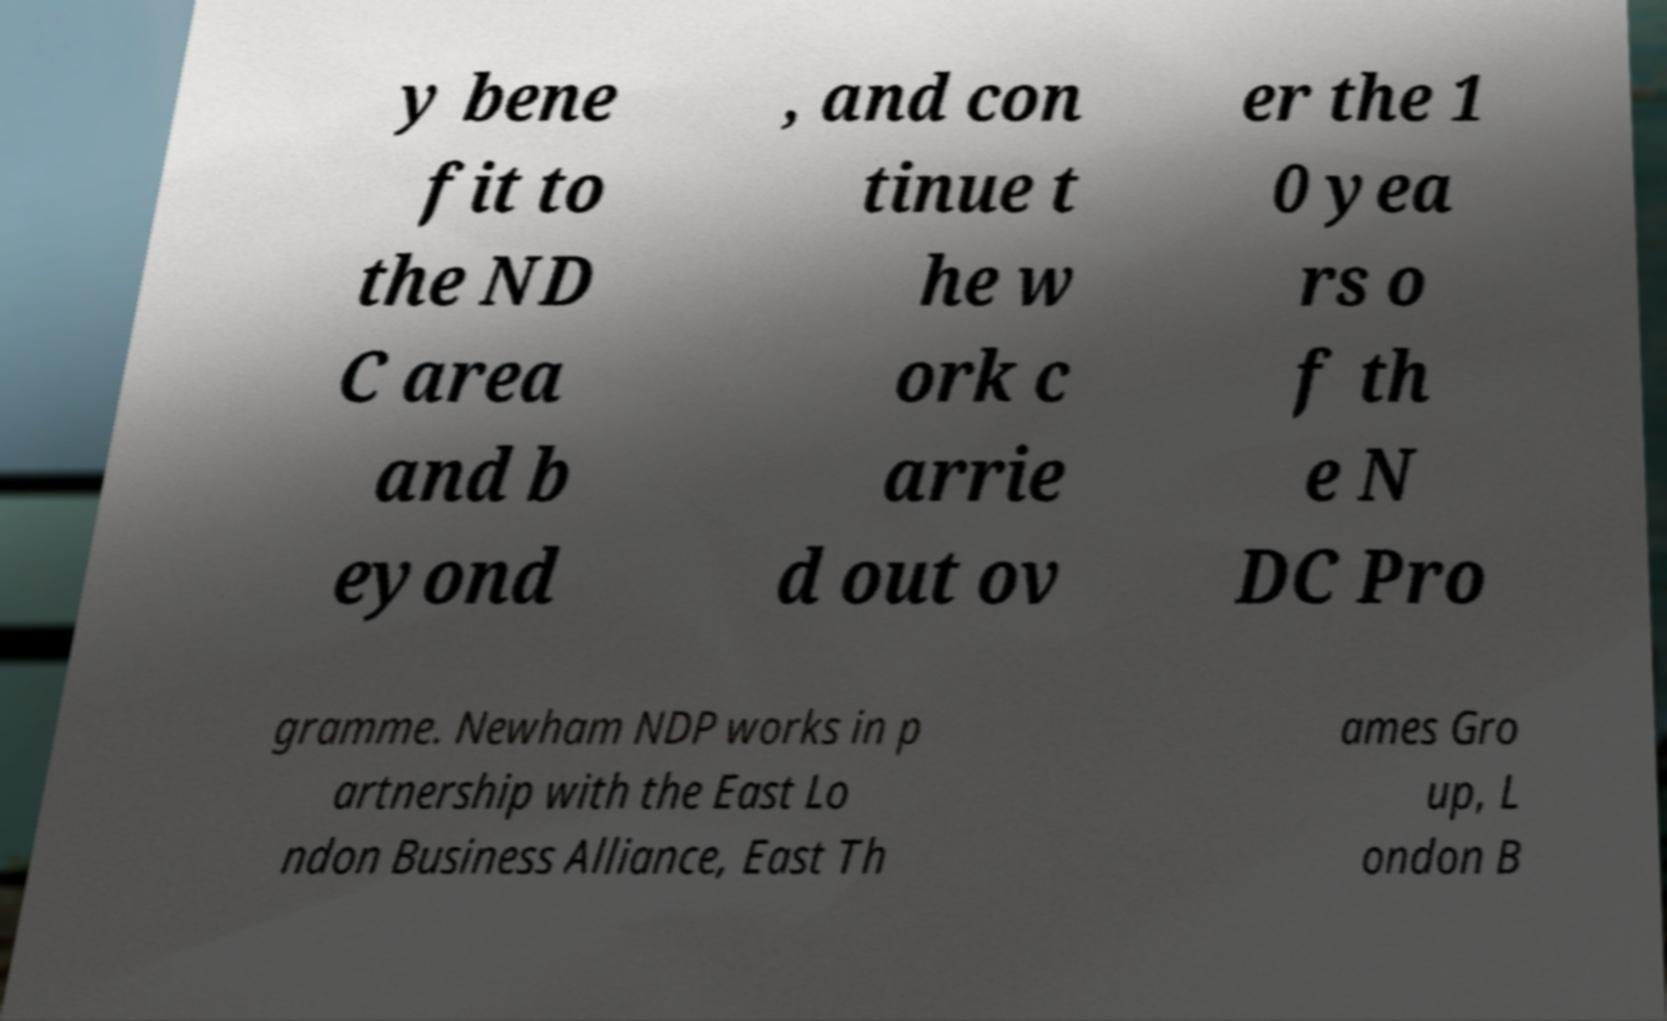Please read and relay the text visible in this image. What does it say? y bene fit to the ND C area and b eyond , and con tinue t he w ork c arrie d out ov er the 1 0 yea rs o f th e N DC Pro gramme. Newham NDP works in p artnership with the East Lo ndon Business Alliance, East Th ames Gro up, L ondon B 